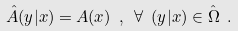Convert formula to latex. <formula><loc_0><loc_0><loc_500><loc_500>\hat { A } ( y | x ) = A ( x ) \ , \ \forall \ ( y | x ) \in \hat { \Omega } \ .</formula> 